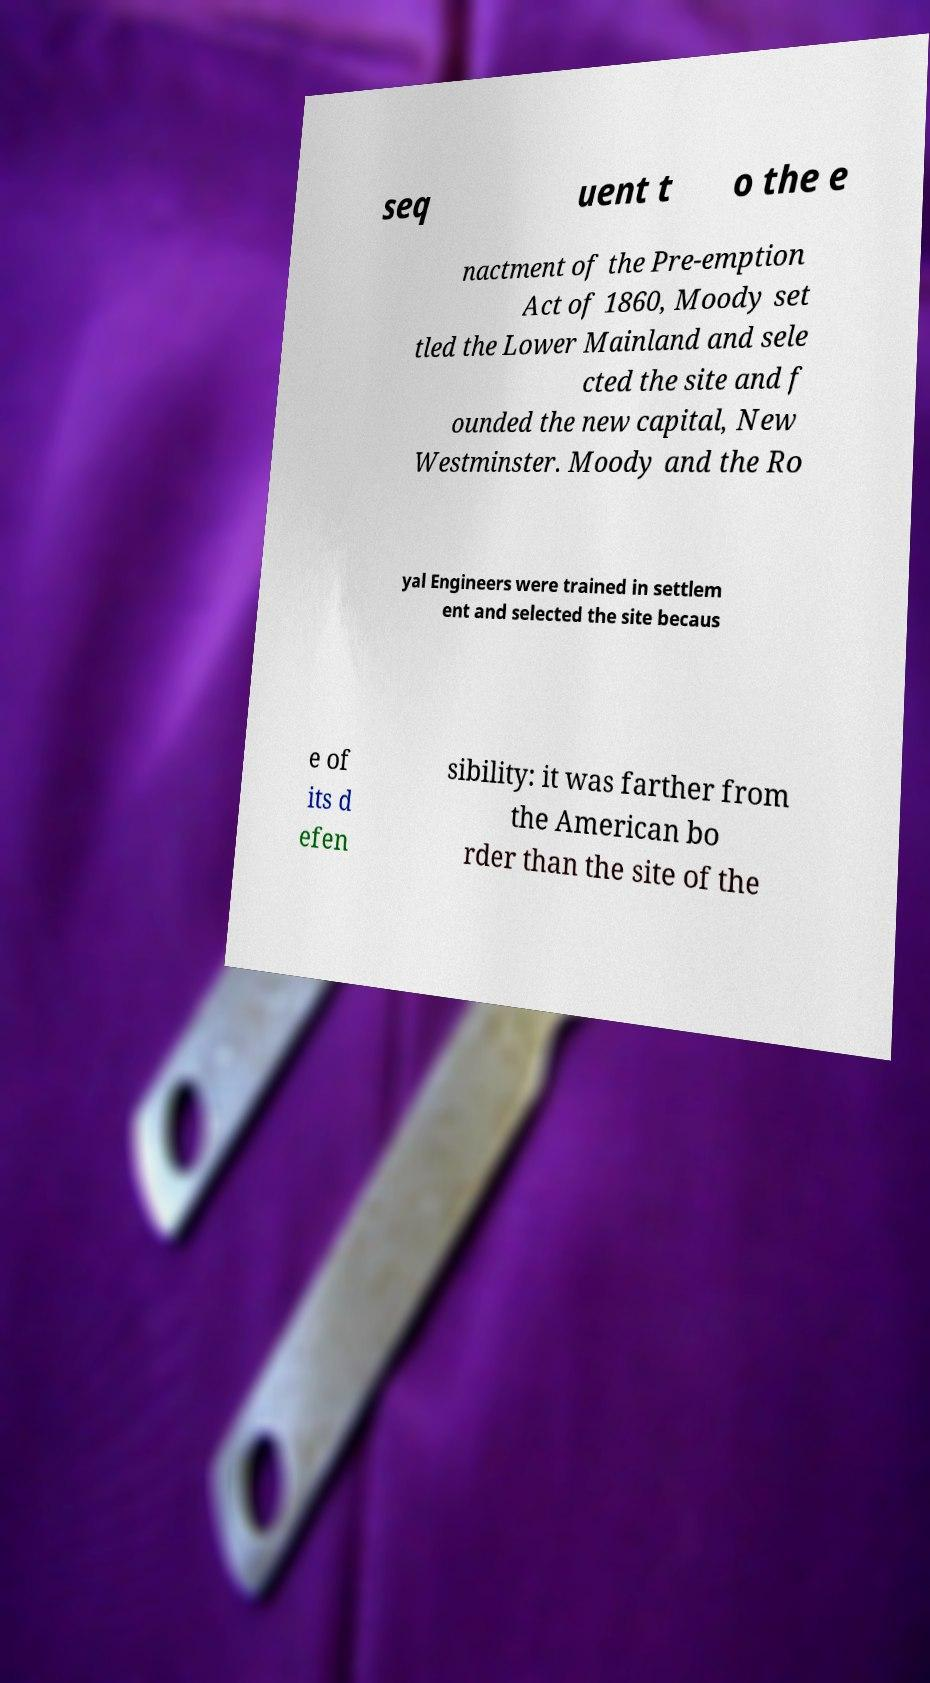Could you extract and type out the text from this image? seq uent t o the e nactment of the Pre-emption Act of 1860, Moody set tled the Lower Mainland and sele cted the site and f ounded the new capital, New Westminster. Moody and the Ro yal Engineers were trained in settlem ent and selected the site becaus e of its d efen sibility: it was farther from the American bo rder than the site of the 